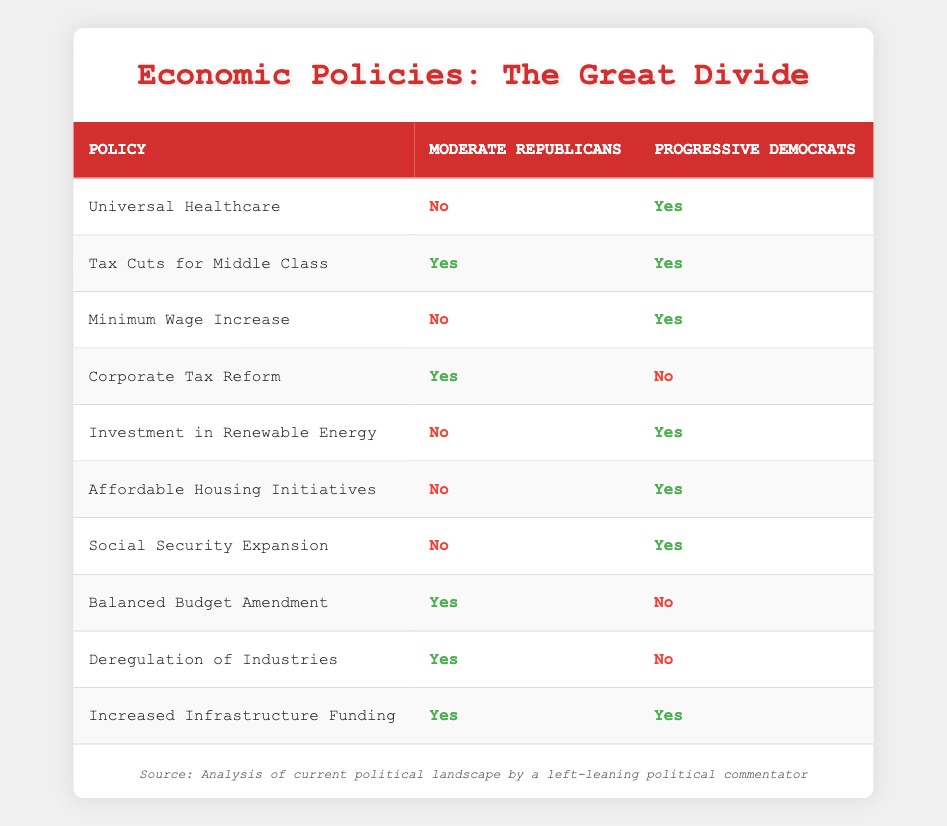What is the stance of moderate Republicans on Universal Healthcare? The table indicates that moderate Republicans support Universal Healthcare with a "No," which directly reflects their position on this policy.
Answer: No Do both moderate Republicans and progressive Democrats support Tax Cuts for the Middle Class? According to the table, both groups support Tax Cuts for the Middle Class with a "Yes" from both moderate Republicans and progressive Democrats.
Answer: Yes How many policies do progressive Democrats support while moderate Republicans oppose? By examining the table, progressive Democrats support a total of six policies while moderate Republicans oppose them: Universal Healthcare, Minimum Wage Increase, Investment in Renewable Energy, Affordable Housing Initiatives, Social Security Expansion, and Corporate Tax Reform.
Answer: 6 Which policy is supported by moderate Republicans but opposed by progressive Democrats? The table lists two policies where moderate Republicans support and progressive Democrats oppose: Corporate Tax Reform and Balanced Budget Amendment.
Answer: Corporate Tax Reform, Balanced Budget Amendment What is the total number of policies each group supports? Counting the support, moderate Republicans advocate for four policies (Tax Cuts for Middle Class, Corporate Tax Reform, Increased Infrastructure Funding, Balanced Budget Amendment), while progressive Democrats advocate for six policies (Universal Healthcare, Minimum Wage Increase, Investment in Renewable Energy, Affordable Housing Initiatives, Social Security Expansion, Increased Infrastructure Funding).
Answer: Moderate Republicans: 4, Progressive Democrats: 6 How many policies do both groups agree on? The table shows that both moderate Republicans and progressive Democrats support one policy in common, which is Increased Infrastructure Funding.
Answer: 1 Does the Balanced Budget Amendment have bipartisan support? The table highlights that the Balanced Budget Amendment has support from moderate Republicans ("Yes") but does not have any support from progressive Democrats ("No"), indicating a lack of bipartisan support for this policy.
Answer: No Out of the policies listed, how many total policies do moderate Republicans oppose? By reviewing the table, moderate Republicans oppose six policies: Universal Healthcare, Minimum Wage Increase, Investment in Renewable Energy, Affordable Housing Initiatives, Social Security Expansion, and Corporate Tax Reform.
Answer: 6 How many policies have unanimous agreement from both parties? A quick look at the table shows that only one policy, Increased Infrastructure Funding, has unanimous agreement, meaning both moderate Republicans and progressive Democrats are in support of it.
Answer: 1 